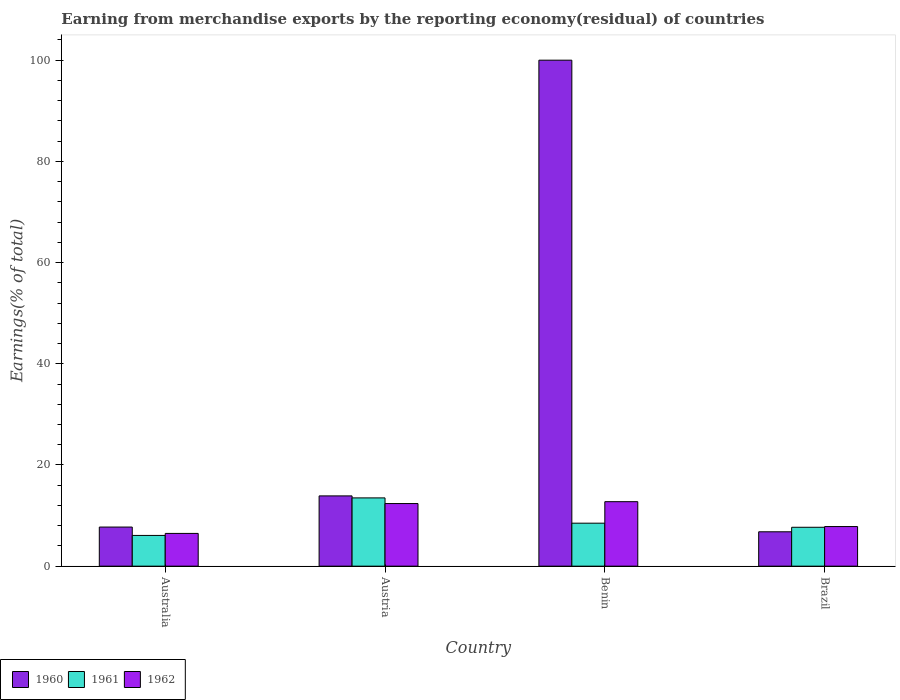How many groups of bars are there?
Offer a terse response. 4. How many bars are there on the 1st tick from the left?
Provide a succinct answer. 3. What is the label of the 3rd group of bars from the left?
Offer a very short reply. Benin. In how many cases, is the number of bars for a given country not equal to the number of legend labels?
Ensure brevity in your answer.  0. What is the percentage of amount earned from merchandise exports in 1960 in Australia?
Make the answer very short. 7.73. Across all countries, what is the maximum percentage of amount earned from merchandise exports in 1961?
Keep it short and to the point. 13.49. Across all countries, what is the minimum percentage of amount earned from merchandise exports in 1961?
Make the answer very short. 6.08. In which country was the percentage of amount earned from merchandise exports in 1962 maximum?
Provide a succinct answer. Benin. In which country was the percentage of amount earned from merchandise exports in 1960 minimum?
Your answer should be compact. Brazil. What is the total percentage of amount earned from merchandise exports in 1961 in the graph?
Your answer should be very brief. 35.75. What is the difference between the percentage of amount earned from merchandise exports in 1961 in Australia and that in Brazil?
Provide a succinct answer. -1.61. What is the difference between the percentage of amount earned from merchandise exports in 1960 in Brazil and the percentage of amount earned from merchandise exports in 1961 in Benin?
Your answer should be very brief. -1.7. What is the average percentage of amount earned from merchandise exports in 1961 per country?
Make the answer very short. 8.94. What is the difference between the percentage of amount earned from merchandise exports of/in 1960 and percentage of amount earned from merchandise exports of/in 1961 in Brazil?
Offer a very short reply. -0.89. In how many countries, is the percentage of amount earned from merchandise exports in 1961 greater than 72 %?
Give a very brief answer. 0. What is the ratio of the percentage of amount earned from merchandise exports in 1961 in Austria to that in Benin?
Your answer should be very brief. 1.59. What is the difference between the highest and the second highest percentage of amount earned from merchandise exports in 1960?
Offer a terse response. 86.11. What is the difference between the highest and the lowest percentage of amount earned from merchandise exports in 1961?
Provide a succinct answer. 7.42. In how many countries, is the percentage of amount earned from merchandise exports in 1960 greater than the average percentage of amount earned from merchandise exports in 1960 taken over all countries?
Offer a very short reply. 1. Are all the bars in the graph horizontal?
Offer a terse response. No. Are the values on the major ticks of Y-axis written in scientific E-notation?
Make the answer very short. No. Does the graph contain any zero values?
Provide a succinct answer. No. Does the graph contain grids?
Your response must be concise. No. Where does the legend appear in the graph?
Ensure brevity in your answer.  Bottom left. How many legend labels are there?
Your answer should be very brief. 3. How are the legend labels stacked?
Offer a terse response. Horizontal. What is the title of the graph?
Provide a succinct answer. Earning from merchandise exports by the reporting economy(residual) of countries. Does "1960" appear as one of the legend labels in the graph?
Offer a very short reply. Yes. What is the label or title of the Y-axis?
Your response must be concise. Earnings(% of total). What is the Earnings(% of total) of 1960 in Australia?
Provide a short and direct response. 7.73. What is the Earnings(% of total) of 1961 in Australia?
Offer a very short reply. 6.08. What is the Earnings(% of total) of 1962 in Australia?
Keep it short and to the point. 6.47. What is the Earnings(% of total) in 1960 in Austria?
Make the answer very short. 13.89. What is the Earnings(% of total) of 1961 in Austria?
Give a very brief answer. 13.49. What is the Earnings(% of total) of 1962 in Austria?
Offer a terse response. 12.38. What is the Earnings(% of total) of 1960 in Benin?
Your answer should be very brief. 100. What is the Earnings(% of total) in 1961 in Benin?
Give a very brief answer. 8.5. What is the Earnings(% of total) in 1962 in Benin?
Make the answer very short. 12.75. What is the Earnings(% of total) in 1960 in Brazil?
Your response must be concise. 6.8. What is the Earnings(% of total) in 1961 in Brazil?
Keep it short and to the point. 7.69. What is the Earnings(% of total) in 1962 in Brazil?
Offer a very short reply. 7.83. Across all countries, what is the maximum Earnings(% of total) in 1961?
Your response must be concise. 13.49. Across all countries, what is the maximum Earnings(% of total) of 1962?
Offer a terse response. 12.75. Across all countries, what is the minimum Earnings(% of total) in 1960?
Offer a terse response. 6.8. Across all countries, what is the minimum Earnings(% of total) of 1961?
Your response must be concise. 6.08. Across all countries, what is the minimum Earnings(% of total) of 1962?
Offer a very short reply. 6.47. What is the total Earnings(% of total) in 1960 in the graph?
Make the answer very short. 128.42. What is the total Earnings(% of total) of 1961 in the graph?
Provide a short and direct response. 35.75. What is the total Earnings(% of total) of 1962 in the graph?
Make the answer very short. 39.42. What is the difference between the Earnings(% of total) in 1960 in Australia and that in Austria?
Your answer should be compact. -6.16. What is the difference between the Earnings(% of total) of 1961 in Australia and that in Austria?
Give a very brief answer. -7.42. What is the difference between the Earnings(% of total) of 1962 in Australia and that in Austria?
Provide a short and direct response. -5.9. What is the difference between the Earnings(% of total) in 1960 in Australia and that in Benin?
Your response must be concise. -92.27. What is the difference between the Earnings(% of total) of 1961 in Australia and that in Benin?
Offer a terse response. -2.42. What is the difference between the Earnings(% of total) in 1962 in Australia and that in Benin?
Your response must be concise. -6.27. What is the difference between the Earnings(% of total) of 1960 in Australia and that in Brazil?
Provide a succinct answer. 0.94. What is the difference between the Earnings(% of total) in 1961 in Australia and that in Brazil?
Make the answer very short. -1.61. What is the difference between the Earnings(% of total) in 1962 in Australia and that in Brazil?
Provide a succinct answer. -1.35. What is the difference between the Earnings(% of total) in 1960 in Austria and that in Benin?
Provide a short and direct response. -86.11. What is the difference between the Earnings(% of total) of 1961 in Austria and that in Benin?
Provide a short and direct response. 4.99. What is the difference between the Earnings(% of total) in 1962 in Austria and that in Benin?
Make the answer very short. -0.37. What is the difference between the Earnings(% of total) in 1960 in Austria and that in Brazil?
Make the answer very short. 7.09. What is the difference between the Earnings(% of total) in 1961 in Austria and that in Brazil?
Your answer should be very brief. 5.81. What is the difference between the Earnings(% of total) in 1962 in Austria and that in Brazil?
Give a very brief answer. 4.55. What is the difference between the Earnings(% of total) in 1960 in Benin and that in Brazil?
Your answer should be very brief. 93.2. What is the difference between the Earnings(% of total) of 1961 in Benin and that in Brazil?
Offer a very short reply. 0.81. What is the difference between the Earnings(% of total) of 1962 in Benin and that in Brazil?
Your answer should be very brief. 4.92. What is the difference between the Earnings(% of total) in 1960 in Australia and the Earnings(% of total) in 1961 in Austria?
Your answer should be very brief. -5.76. What is the difference between the Earnings(% of total) in 1960 in Australia and the Earnings(% of total) in 1962 in Austria?
Ensure brevity in your answer.  -4.64. What is the difference between the Earnings(% of total) in 1961 in Australia and the Earnings(% of total) in 1962 in Austria?
Ensure brevity in your answer.  -6.3. What is the difference between the Earnings(% of total) in 1960 in Australia and the Earnings(% of total) in 1961 in Benin?
Your response must be concise. -0.77. What is the difference between the Earnings(% of total) in 1960 in Australia and the Earnings(% of total) in 1962 in Benin?
Keep it short and to the point. -5.01. What is the difference between the Earnings(% of total) in 1961 in Australia and the Earnings(% of total) in 1962 in Benin?
Your response must be concise. -6.67. What is the difference between the Earnings(% of total) of 1960 in Australia and the Earnings(% of total) of 1961 in Brazil?
Offer a terse response. 0.05. What is the difference between the Earnings(% of total) in 1960 in Australia and the Earnings(% of total) in 1962 in Brazil?
Offer a terse response. -0.1. What is the difference between the Earnings(% of total) of 1961 in Australia and the Earnings(% of total) of 1962 in Brazil?
Provide a short and direct response. -1.75. What is the difference between the Earnings(% of total) in 1960 in Austria and the Earnings(% of total) in 1961 in Benin?
Give a very brief answer. 5.39. What is the difference between the Earnings(% of total) in 1960 in Austria and the Earnings(% of total) in 1962 in Benin?
Give a very brief answer. 1.14. What is the difference between the Earnings(% of total) in 1961 in Austria and the Earnings(% of total) in 1962 in Benin?
Provide a succinct answer. 0.75. What is the difference between the Earnings(% of total) of 1960 in Austria and the Earnings(% of total) of 1961 in Brazil?
Provide a short and direct response. 6.2. What is the difference between the Earnings(% of total) in 1960 in Austria and the Earnings(% of total) in 1962 in Brazil?
Give a very brief answer. 6.06. What is the difference between the Earnings(% of total) in 1961 in Austria and the Earnings(% of total) in 1962 in Brazil?
Keep it short and to the point. 5.66. What is the difference between the Earnings(% of total) in 1960 in Benin and the Earnings(% of total) in 1961 in Brazil?
Your answer should be very brief. 92.31. What is the difference between the Earnings(% of total) in 1960 in Benin and the Earnings(% of total) in 1962 in Brazil?
Provide a succinct answer. 92.17. What is the difference between the Earnings(% of total) of 1961 in Benin and the Earnings(% of total) of 1962 in Brazil?
Offer a very short reply. 0.67. What is the average Earnings(% of total) in 1960 per country?
Make the answer very short. 32.1. What is the average Earnings(% of total) of 1961 per country?
Your response must be concise. 8.94. What is the average Earnings(% of total) of 1962 per country?
Give a very brief answer. 9.86. What is the difference between the Earnings(% of total) in 1960 and Earnings(% of total) in 1961 in Australia?
Provide a short and direct response. 1.65. What is the difference between the Earnings(% of total) in 1960 and Earnings(% of total) in 1962 in Australia?
Offer a very short reply. 1.26. What is the difference between the Earnings(% of total) of 1961 and Earnings(% of total) of 1962 in Australia?
Your answer should be compact. -0.4. What is the difference between the Earnings(% of total) of 1960 and Earnings(% of total) of 1961 in Austria?
Ensure brevity in your answer.  0.4. What is the difference between the Earnings(% of total) of 1960 and Earnings(% of total) of 1962 in Austria?
Ensure brevity in your answer.  1.51. What is the difference between the Earnings(% of total) in 1961 and Earnings(% of total) in 1962 in Austria?
Ensure brevity in your answer.  1.12. What is the difference between the Earnings(% of total) in 1960 and Earnings(% of total) in 1961 in Benin?
Give a very brief answer. 91.5. What is the difference between the Earnings(% of total) of 1960 and Earnings(% of total) of 1962 in Benin?
Offer a very short reply. 87.25. What is the difference between the Earnings(% of total) in 1961 and Earnings(% of total) in 1962 in Benin?
Ensure brevity in your answer.  -4.25. What is the difference between the Earnings(% of total) in 1960 and Earnings(% of total) in 1961 in Brazil?
Offer a terse response. -0.89. What is the difference between the Earnings(% of total) of 1960 and Earnings(% of total) of 1962 in Brazil?
Your answer should be very brief. -1.03. What is the difference between the Earnings(% of total) in 1961 and Earnings(% of total) in 1962 in Brazil?
Offer a terse response. -0.14. What is the ratio of the Earnings(% of total) of 1960 in Australia to that in Austria?
Give a very brief answer. 0.56. What is the ratio of the Earnings(% of total) of 1961 in Australia to that in Austria?
Provide a succinct answer. 0.45. What is the ratio of the Earnings(% of total) in 1962 in Australia to that in Austria?
Your answer should be compact. 0.52. What is the ratio of the Earnings(% of total) in 1960 in Australia to that in Benin?
Keep it short and to the point. 0.08. What is the ratio of the Earnings(% of total) in 1961 in Australia to that in Benin?
Offer a terse response. 0.72. What is the ratio of the Earnings(% of total) of 1962 in Australia to that in Benin?
Offer a terse response. 0.51. What is the ratio of the Earnings(% of total) in 1960 in Australia to that in Brazil?
Offer a terse response. 1.14. What is the ratio of the Earnings(% of total) in 1961 in Australia to that in Brazil?
Your answer should be very brief. 0.79. What is the ratio of the Earnings(% of total) in 1962 in Australia to that in Brazil?
Provide a short and direct response. 0.83. What is the ratio of the Earnings(% of total) in 1960 in Austria to that in Benin?
Your answer should be compact. 0.14. What is the ratio of the Earnings(% of total) of 1961 in Austria to that in Benin?
Provide a succinct answer. 1.59. What is the ratio of the Earnings(% of total) in 1962 in Austria to that in Benin?
Give a very brief answer. 0.97. What is the ratio of the Earnings(% of total) of 1960 in Austria to that in Brazil?
Provide a short and direct response. 2.04. What is the ratio of the Earnings(% of total) in 1961 in Austria to that in Brazil?
Offer a very short reply. 1.76. What is the ratio of the Earnings(% of total) in 1962 in Austria to that in Brazil?
Make the answer very short. 1.58. What is the ratio of the Earnings(% of total) in 1960 in Benin to that in Brazil?
Keep it short and to the point. 14.71. What is the ratio of the Earnings(% of total) of 1961 in Benin to that in Brazil?
Your answer should be very brief. 1.11. What is the ratio of the Earnings(% of total) of 1962 in Benin to that in Brazil?
Your answer should be compact. 1.63. What is the difference between the highest and the second highest Earnings(% of total) of 1960?
Keep it short and to the point. 86.11. What is the difference between the highest and the second highest Earnings(% of total) of 1961?
Give a very brief answer. 4.99. What is the difference between the highest and the second highest Earnings(% of total) in 1962?
Offer a terse response. 0.37. What is the difference between the highest and the lowest Earnings(% of total) of 1960?
Keep it short and to the point. 93.2. What is the difference between the highest and the lowest Earnings(% of total) in 1961?
Ensure brevity in your answer.  7.42. What is the difference between the highest and the lowest Earnings(% of total) in 1962?
Give a very brief answer. 6.27. 